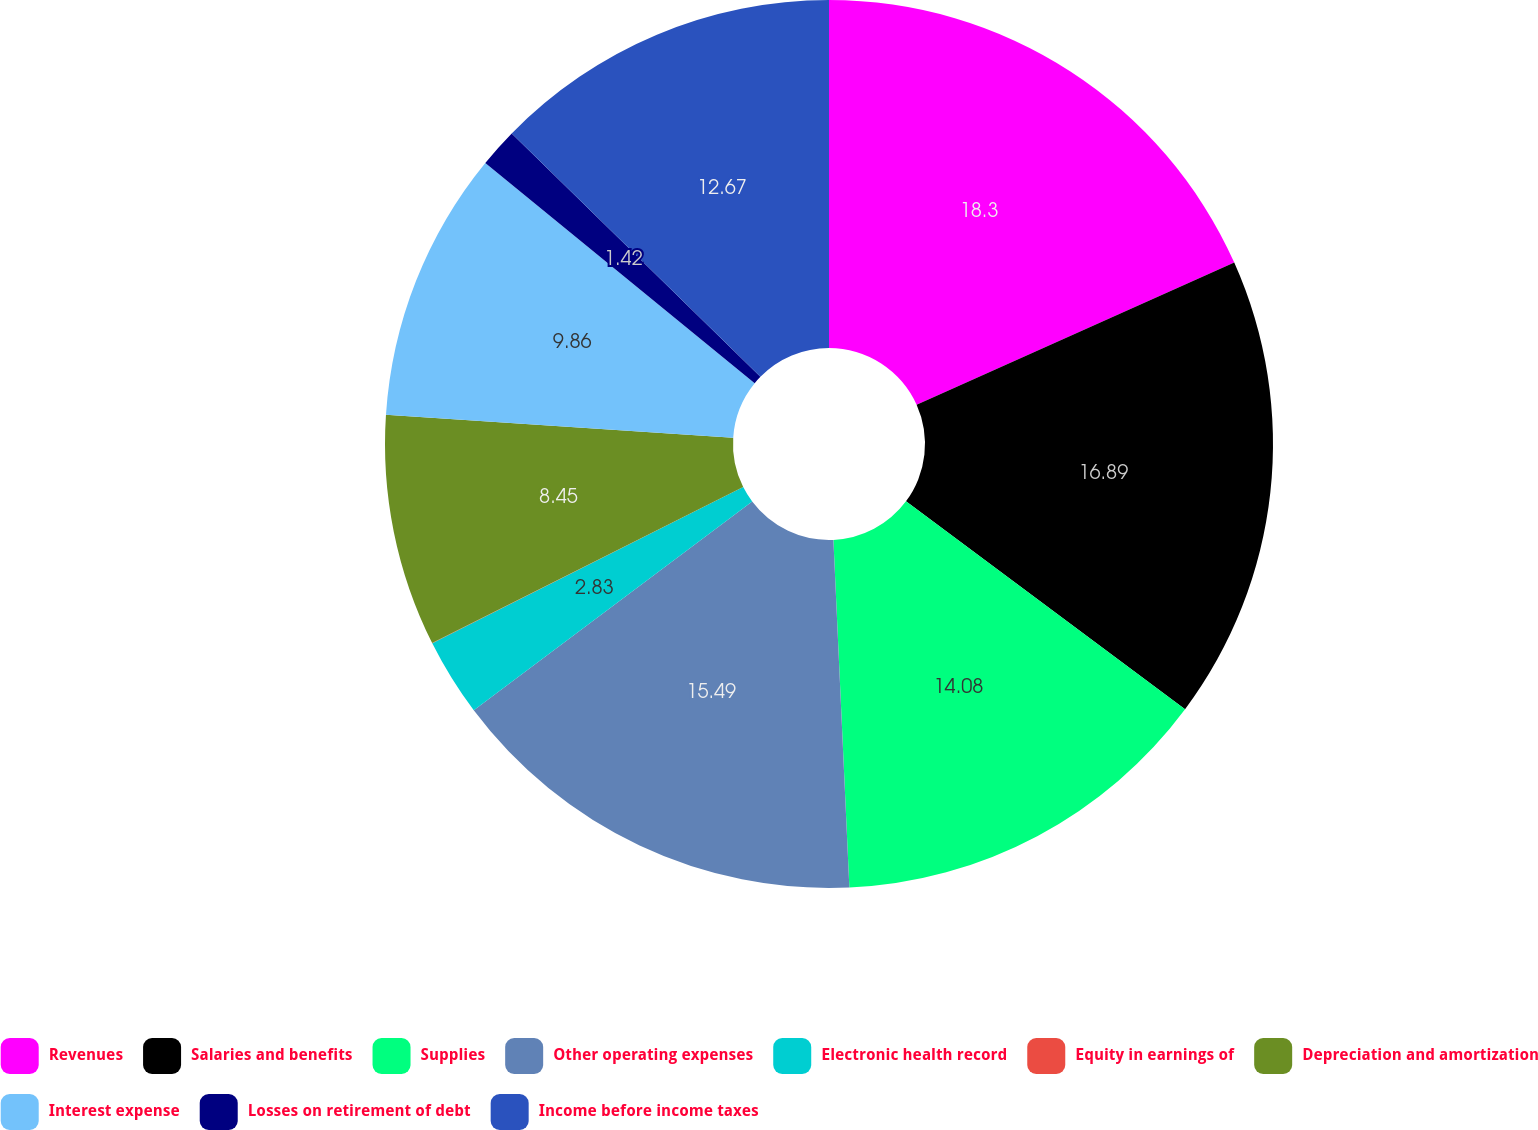<chart> <loc_0><loc_0><loc_500><loc_500><pie_chart><fcel>Revenues<fcel>Salaries and benefits<fcel>Supplies<fcel>Other operating expenses<fcel>Electronic health record<fcel>Equity in earnings of<fcel>Depreciation and amortization<fcel>Interest expense<fcel>Losses on retirement of debt<fcel>Income before income taxes<nl><fcel>18.3%<fcel>16.89%<fcel>14.08%<fcel>15.49%<fcel>2.83%<fcel>0.01%<fcel>8.45%<fcel>9.86%<fcel>1.42%<fcel>12.67%<nl></chart> 